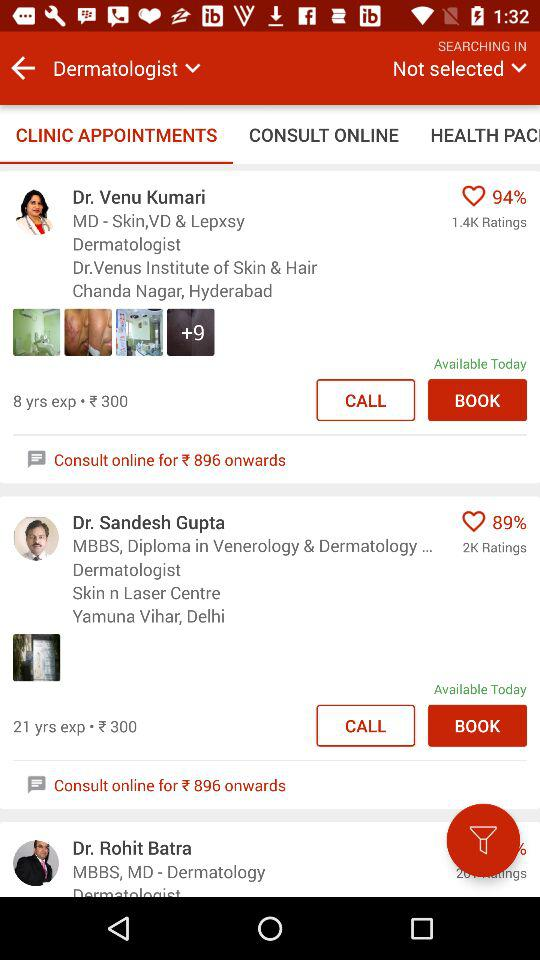How many ratings does Dr. Sandesh Gupta have? Dr. Sandesh Gupta has 2K ratings. 